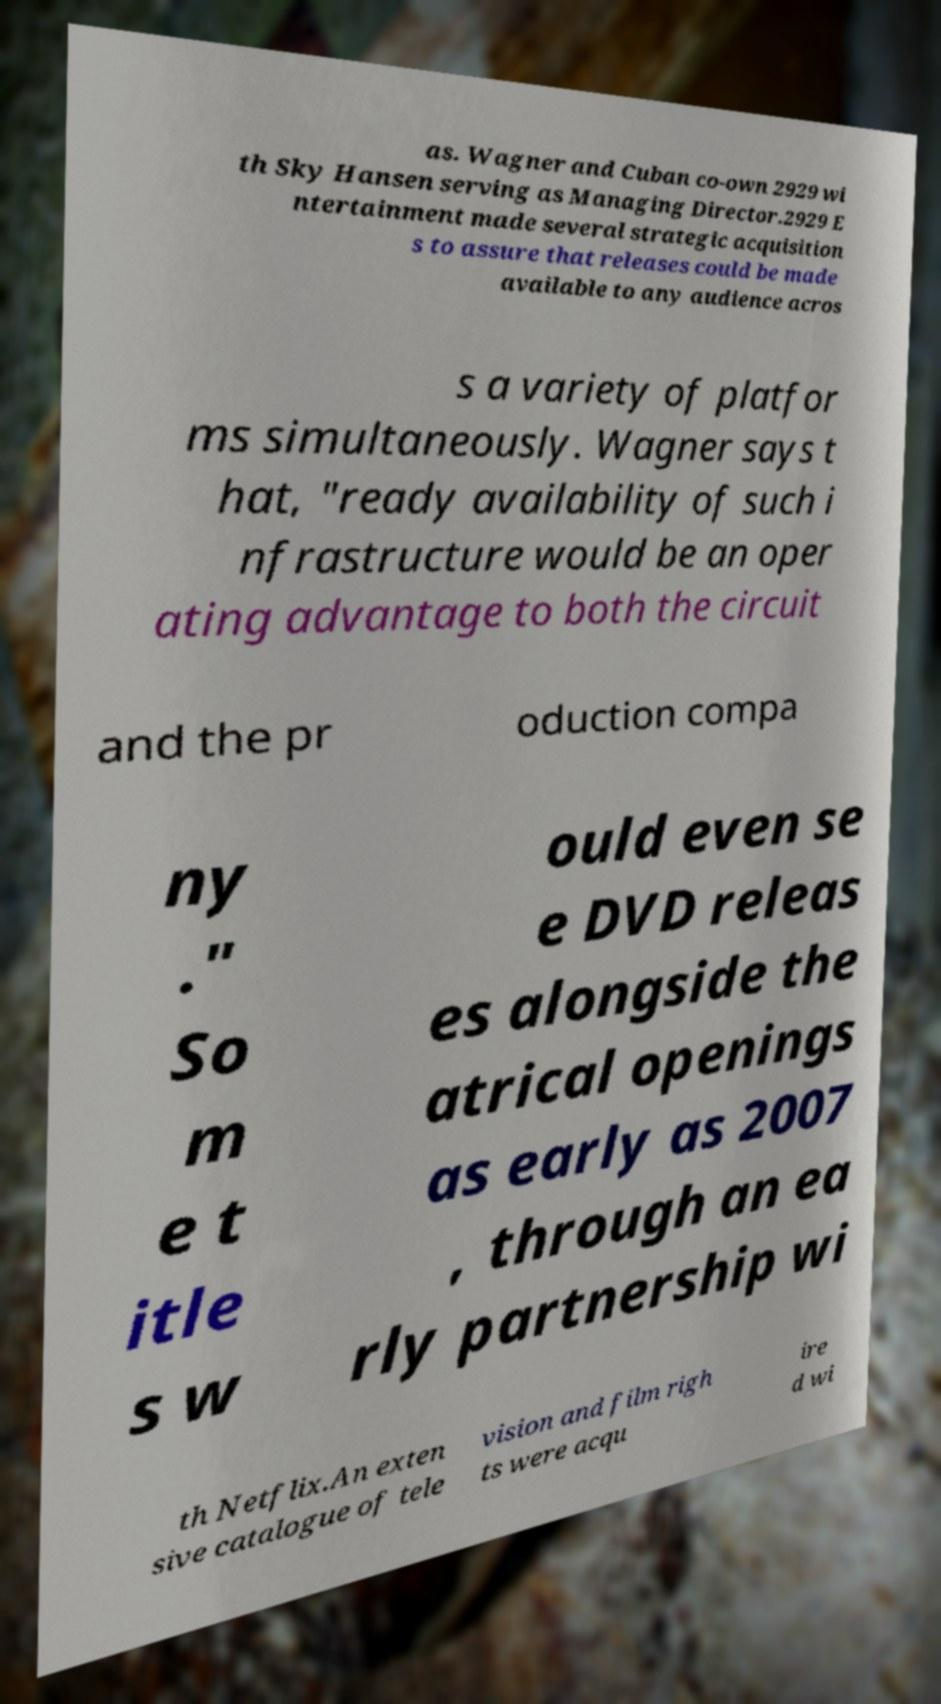Can you read and provide the text displayed in the image?This photo seems to have some interesting text. Can you extract and type it out for me? as. Wagner and Cuban co-own 2929 wi th Sky Hansen serving as Managing Director.2929 E ntertainment made several strategic acquisition s to assure that releases could be made available to any audience acros s a variety of platfor ms simultaneously. Wagner says t hat, "ready availability of such i nfrastructure would be an oper ating advantage to both the circuit and the pr oduction compa ny ." So m e t itle s w ould even se e DVD releas es alongside the atrical openings as early as 2007 , through an ea rly partnership wi th Netflix.An exten sive catalogue of tele vision and film righ ts were acqu ire d wi 